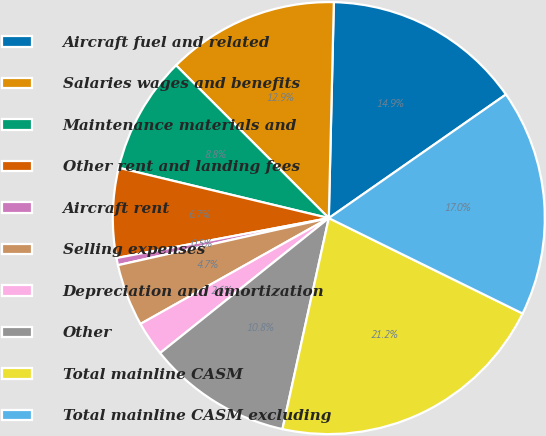Convert chart. <chart><loc_0><loc_0><loc_500><loc_500><pie_chart><fcel>Aircraft fuel and related<fcel>Salaries wages and benefits<fcel>Maintenance materials and<fcel>Other rent and landing fees<fcel>Aircraft rent<fcel>Selling expenses<fcel>Depreciation and amortization<fcel>Other<fcel>Total mainline CASM<fcel>Total mainline CASM excluding<nl><fcel>14.93%<fcel>12.87%<fcel>8.76%<fcel>6.7%<fcel>0.54%<fcel>4.65%<fcel>2.59%<fcel>10.82%<fcel>21.16%<fcel>16.98%<nl></chart> 